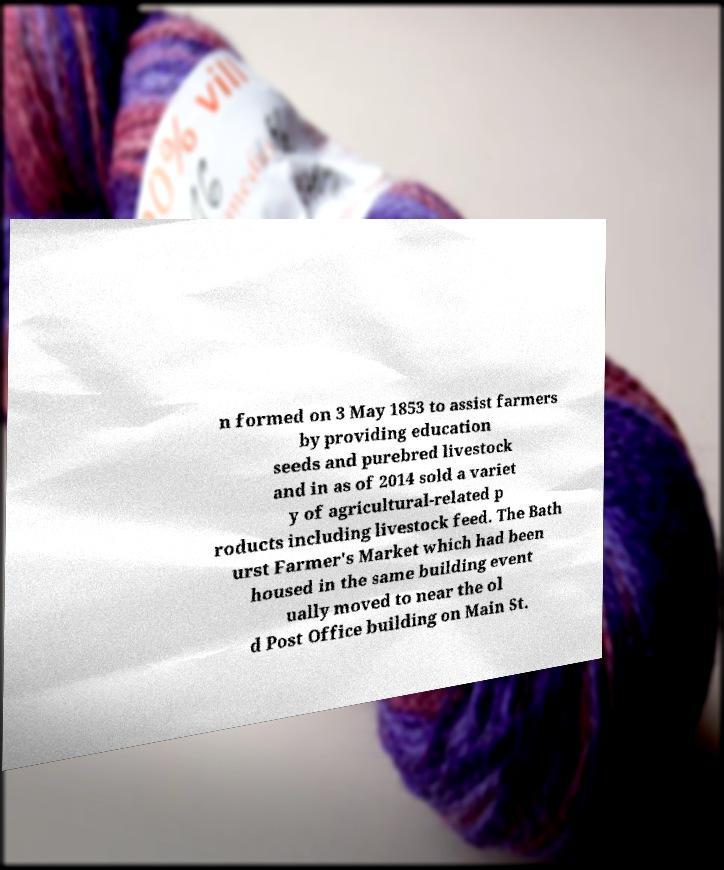What messages or text are displayed in this image? I need them in a readable, typed format. n formed on 3 May 1853 to assist farmers by providing education seeds and purebred livestock and in as of 2014 sold a variet y of agricultural-related p roducts including livestock feed. The Bath urst Farmer's Market which had been housed in the same building event ually moved to near the ol d Post Office building on Main St. 